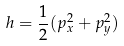<formula> <loc_0><loc_0><loc_500><loc_500>h = \frac { 1 } { 2 } ( p _ { x } ^ { 2 } + p _ { y } ^ { 2 } )</formula> 